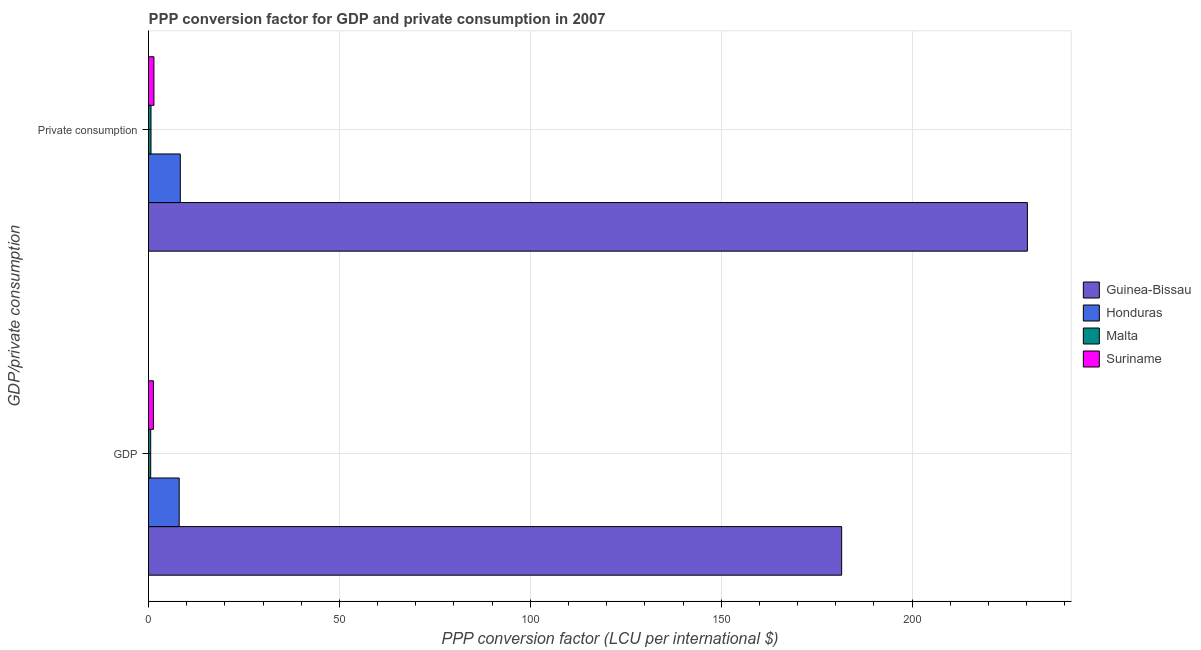How many different coloured bars are there?
Ensure brevity in your answer.  4. How many bars are there on the 1st tick from the top?
Your answer should be compact. 4. What is the label of the 2nd group of bars from the top?
Ensure brevity in your answer.  GDP. What is the ppp conversion factor for private consumption in Guinea-Bissau?
Your answer should be compact. 230.19. Across all countries, what is the maximum ppp conversion factor for private consumption?
Offer a terse response. 230.19. Across all countries, what is the minimum ppp conversion factor for gdp?
Offer a very short reply. 0.57. In which country was the ppp conversion factor for private consumption maximum?
Offer a terse response. Guinea-Bissau. In which country was the ppp conversion factor for private consumption minimum?
Ensure brevity in your answer.  Malta. What is the total ppp conversion factor for gdp in the graph?
Offer a terse response. 191.43. What is the difference between the ppp conversion factor for private consumption in Guinea-Bissau and that in Honduras?
Provide a succinct answer. 221.87. What is the difference between the ppp conversion factor for private consumption in Guinea-Bissau and the ppp conversion factor for gdp in Suriname?
Give a very brief answer. 228.91. What is the average ppp conversion factor for private consumption per country?
Your answer should be very brief. 60.15. What is the difference between the ppp conversion factor for gdp and ppp conversion factor for private consumption in Malta?
Keep it short and to the point. -0.08. In how many countries, is the ppp conversion factor for gdp greater than 220 LCU?
Provide a short and direct response. 0. What is the ratio of the ppp conversion factor for gdp in Malta to that in Honduras?
Offer a terse response. 0.07. In how many countries, is the ppp conversion factor for private consumption greater than the average ppp conversion factor for private consumption taken over all countries?
Your response must be concise. 1. What does the 3rd bar from the top in  Private consumption represents?
Provide a succinct answer. Honduras. What does the 3rd bar from the bottom in GDP represents?
Make the answer very short. Malta. How many bars are there?
Keep it short and to the point. 8. Are all the bars in the graph horizontal?
Give a very brief answer. Yes. What is the difference between two consecutive major ticks on the X-axis?
Your answer should be compact. 50. Are the values on the major ticks of X-axis written in scientific E-notation?
Offer a very short reply. No. Does the graph contain any zero values?
Offer a terse response. No. Does the graph contain grids?
Give a very brief answer. Yes. How many legend labels are there?
Offer a terse response. 4. What is the title of the graph?
Your response must be concise. PPP conversion factor for GDP and private consumption in 2007. Does "Europe(developing only)" appear as one of the legend labels in the graph?
Give a very brief answer. No. What is the label or title of the X-axis?
Your answer should be very brief. PPP conversion factor (LCU per international $). What is the label or title of the Y-axis?
Give a very brief answer. GDP/private consumption. What is the PPP conversion factor (LCU per international $) of Guinea-Bissau in GDP?
Your response must be concise. 181.55. What is the PPP conversion factor (LCU per international $) of Honduras in GDP?
Your answer should be compact. 8.04. What is the PPP conversion factor (LCU per international $) in Malta in GDP?
Make the answer very short. 0.57. What is the PPP conversion factor (LCU per international $) in Suriname in GDP?
Offer a terse response. 1.28. What is the PPP conversion factor (LCU per international $) of Guinea-Bissau in  Private consumption?
Give a very brief answer. 230.19. What is the PPP conversion factor (LCU per international $) of Honduras in  Private consumption?
Make the answer very short. 8.32. What is the PPP conversion factor (LCU per international $) of Malta in  Private consumption?
Ensure brevity in your answer.  0.65. What is the PPP conversion factor (LCU per international $) of Suriname in  Private consumption?
Provide a succinct answer. 1.42. Across all GDP/private consumption, what is the maximum PPP conversion factor (LCU per international $) in Guinea-Bissau?
Provide a short and direct response. 230.19. Across all GDP/private consumption, what is the maximum PPP conversion factor (LCU per international $) in Honduras?
Keep it short and to the point. 8.32. Across all GDP/private consumption, what is the maximum PPP conversion factor (LCU per international $) of Malta?
Provide a succinct answer. 0.65. Across all GDP/private consumption, what is the maximum PPP conversion factor (LCU per international $) of Suriname?
Provide a short and direct response. 1.42. Across all GDP/private consumption, what is the minimum PPP conversion factor (LCU per international $) in Guinea-Bissau?
Ensure brevity in your answer.  181.55. Across all GDP/private consumption, what is the minimum PPP conversion factor (LCU per international $) of Honduras?
Provide a succinct answer. 8.04. Across all GDP/private consumption, what is the minimum PPP conversion factor (LCU per international $) of Malta?
Offer a terse response. 0.57. Across all GDP/private consumption, what is the minimum PPP conversion factor (LCU per international $) of Suriname?
Make the answer very short. 1.28. What is the total PPP conversion factor (LCU per international $) of Guinea-Bissau in the graph?
Your answer should be compact. 411.74. What is the total PPP conversion factor (LCU per international $) of Honduras in the graph?
Provide a short and direct response. 16.36. What is the total PPP conversion factor (LCU per international $) in Malta in the graph?
Your answer should be very brief. 1.22. What is the total PPP conversion factor (LCU per international $) in Suriname in the graph?
Offer a terse response. 2.7. What is the difference between the PPP conversion factor (LCU per international $) of Guinea-Bissau in GDP and that in  Private consumption?
Your answer should be very brief. -48.65. What is the difference between the PPP conversion factor (LCU per international $) in Honduras in GDP and that in  Private consumption?
Provide a short and direct response. -0.29. What is the difference between the PPP conversion factor (LCU per international $) in Malta in GDP and that in  Private consumption?
Provide a short and direct response. -0.08. What is the difference between the PPP conversion factor (LCU per international $) in Suriname in GDP and that in  Private consumption?
Keep it short and to the point. -0.14. What is the difference between the PPP conversion factor (LCU per international $) in Guinea-Bissau in GDP and the PPP conversion factor (LCU per international $) in Honduras in  Private consumption?
Make the answer very short. 173.22. What is the difference between the PPP conversion factor (LCU per international $) of Guinea-Bissau in GDP and the PPP conversion factor (LCU per international $) of Malta in  Private consumption?
Offer a terse response. 180.9. What is the difference between the PPP conversion factor (LCU per international $) of Guinea-Bissau in GDP and the PPP conversion factor (LCU per international $) of Suriname in  Private consumption?
Your answer should be compact. 180.13. What is the difference between the PPP conversion factor (LCU per international $) in Honduras in GDP and the PPP conversion factor (LCU per international $) in Malta in  Private consumption?
Your response must be concise. 7.39. What is the difference between the PPP conversion factor (LCU per international $) in Honduras in GDP and the PPP conversion factor (LCU per international $) in Suriname in  Private consumption?
Offer a very short reply. 6.62. What is the difference between the PPP conversion factor (LCU per international $) of Malta in GDP and the PPP conversion factor (LCU per international $) of Suriname in  Private consumption?
Your answer should be very brief. -0.85. What is the average PPP conversion factor (LCU per international $) in Guinea-Bissau per GDP/private consumption?
Offer a very short reply. 205.87. What is the average PPP conversion factor (LCU per international $) of Honduras per GDP/private consumption?
Your answer should be compact. 8.18. What is the average PPP conversion factor (LCU per international $) in Malta per GDP/private consumption?
Ensure brevity in your answer.  0.61. What is the average PPP conversion factor (LCU per international $) of Suriname per GDP/private consumption?
Your response must be concise. 1.35. What is the difference between the PPP conversion factor (LCU per international $) of Guinea-Bissau and PPP conversion factor (LCU per international $) of Honduras in GDP?
Keep it short and to the point. 173.51. What is the difference between the PPP conversion factor (LCU per international $) in Guinea-Bissau and PPP conversion factor (LCU per international $) in Malta in GDP?
Make the answer very short. 180.98. What is the difference between the PPP conversion factor (LCU per international $) of Guinea-Bissau and PPP conversion factor (LCU per international $) of Suriname in GDP?
Give a very brief answer. 180.26. What is the difference between the PPP conversion factor (LCU per international $) of Honduras and PPP conversion factor (LCU per international $) of Malta in GDP?
Offer a very short reply. 7.47. What is the difference between the PPP conversion factor (LCU per international $) of Honduras and PPP conversion factor (LCU per international $) of Suriname in GDP?
Your answer should be very brief. 6.75. What is the difference between the PPP conversion factor (LCU per international $) of Malta and PPP conversion factor (LCU per international $) of Suriname in GDP?
Ensure brevity in your answer.  -0.72. What is the difference between the PPP conversion factor (LCU per international $) in Guinea-Bissau and PPP conversion factor (LCU per international $) in Honduras in  Private consumption?
Give a very brief answer. 221.87. What is the difference between the PPP conversion factor (LCU per international $) in Guinea-Bissau and PPP conversion factor (LCU per international $) in Malta in  Private consumption?
Your answer should be compact. 229.54. What is the difference between the PPP conversion factor (LCU per international $) in Guinea-Bissau and PPP conversion factor (LCU per international $) in Suriname in  Private consumption?
Keep it short and to the point. 228.77. What is the difference between the PPP conversion factor (LCU per international $) of Honduras and PPP conversion factor (LCU per international $) of Malta in  Private consumption?
Keep it short and to the point. 7.68. What is the difference between the PPP conversion factor (LCU per international $) in Honduras and PPP conversion factor (LCU per international $) in Suriname in  Private consumption?
Make the answer very short. 6.91. What is the difference between the PPP conversion factor (LCU per international $) in Malta and PPP conversion factor (LCU per international $) in Suriname in  Private consumption?
Offer a terse response. -0.77. What is the ratio of the PPP conversion factor (LCU per international $) in Guinea-Bissau in GDP to that in  Private consumption?
Keep it short and to the point. 0.79. What is the ratio of the PPP conversion factor (LCU per international $) in Honduras in GDP to that in  Private consumption?
Offer a very short reply. 0.97. What is the ratio of the PPP conversion factor (LCU per international $) of Malta in GDP to that in  Private consumption?
Offer a very short reply. 0.88. What is the ratio of the PPP conversion factor (LCU per international $) of Suriname in GDP to that in  Private consumption?
Provide a succinct answer. 0.9. What is the difference between the highest and the second highest PPP conversion factor (LCU per international $) of Guinea-Bissau?
Your answer should be very brief. 48.65. What is the difference between the highest and the second highest PPP conversion factor (LCU per international $) in Honduras?
Provide a succinct answer. 0.29. What is the difference between the highest and the second highest PPP conversion factor (LCU per international $) of Malta?
Provide a succinct answer. 0.08. What is the difference between the highest and the second highest PPP conversion factor (LCU per international $) of Suriname?
Offer a very short reply. 0.14. What is the difference between the highest and the lowest PPP conversion factor (LCU per international $) in Guinea-Bissau?
Offer a terse response. 48.65. What is the difference between the highest and the lowest PPP conversion factor (LCU per international $) of Honduras?
Make the answer very short. 0.29. What is the difference between the highest and the lowest PPP conversion factor (LCU per international $) of Malta?
Give a very brief answer. 0.08. What is the difference between the highest and the lowest PPP conversion factor (LCU per international $) of Suriname?
Give a very brief answer. 0.14. 